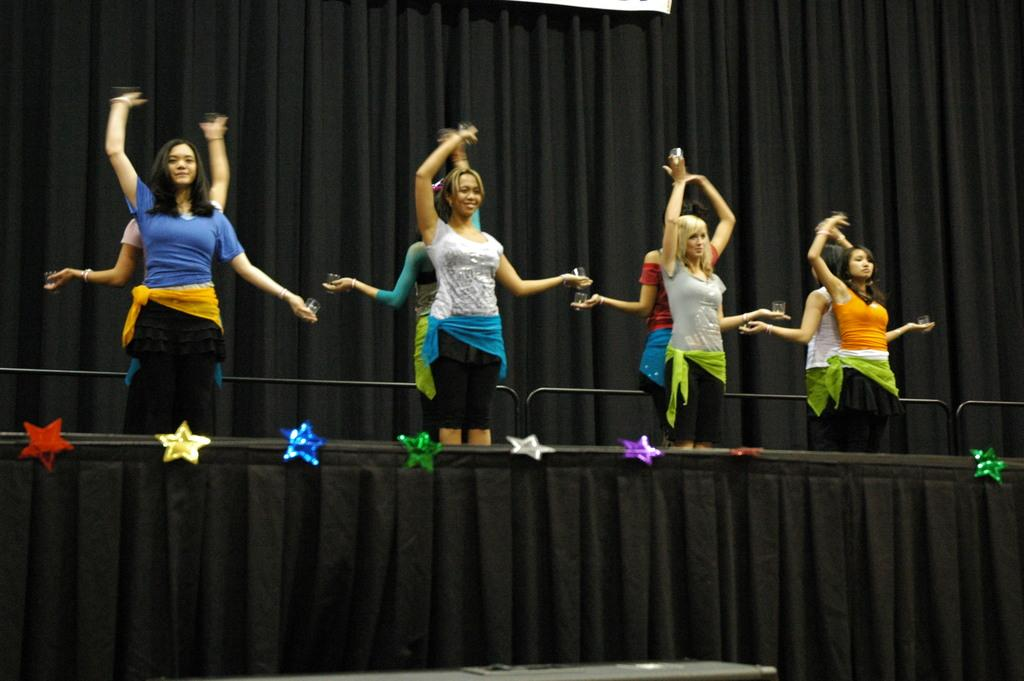What are the women in the image doing? The women in the image are dancing on the stage. How is the stage decorated? The stage is decorated with stars. What color is the curtain behind the women? The curtain behind the women is black. How many kittens are playing with a mitten on the stage? There are no kittens or mittens present in the image; it features women dancing on a stage decorated with stars. 